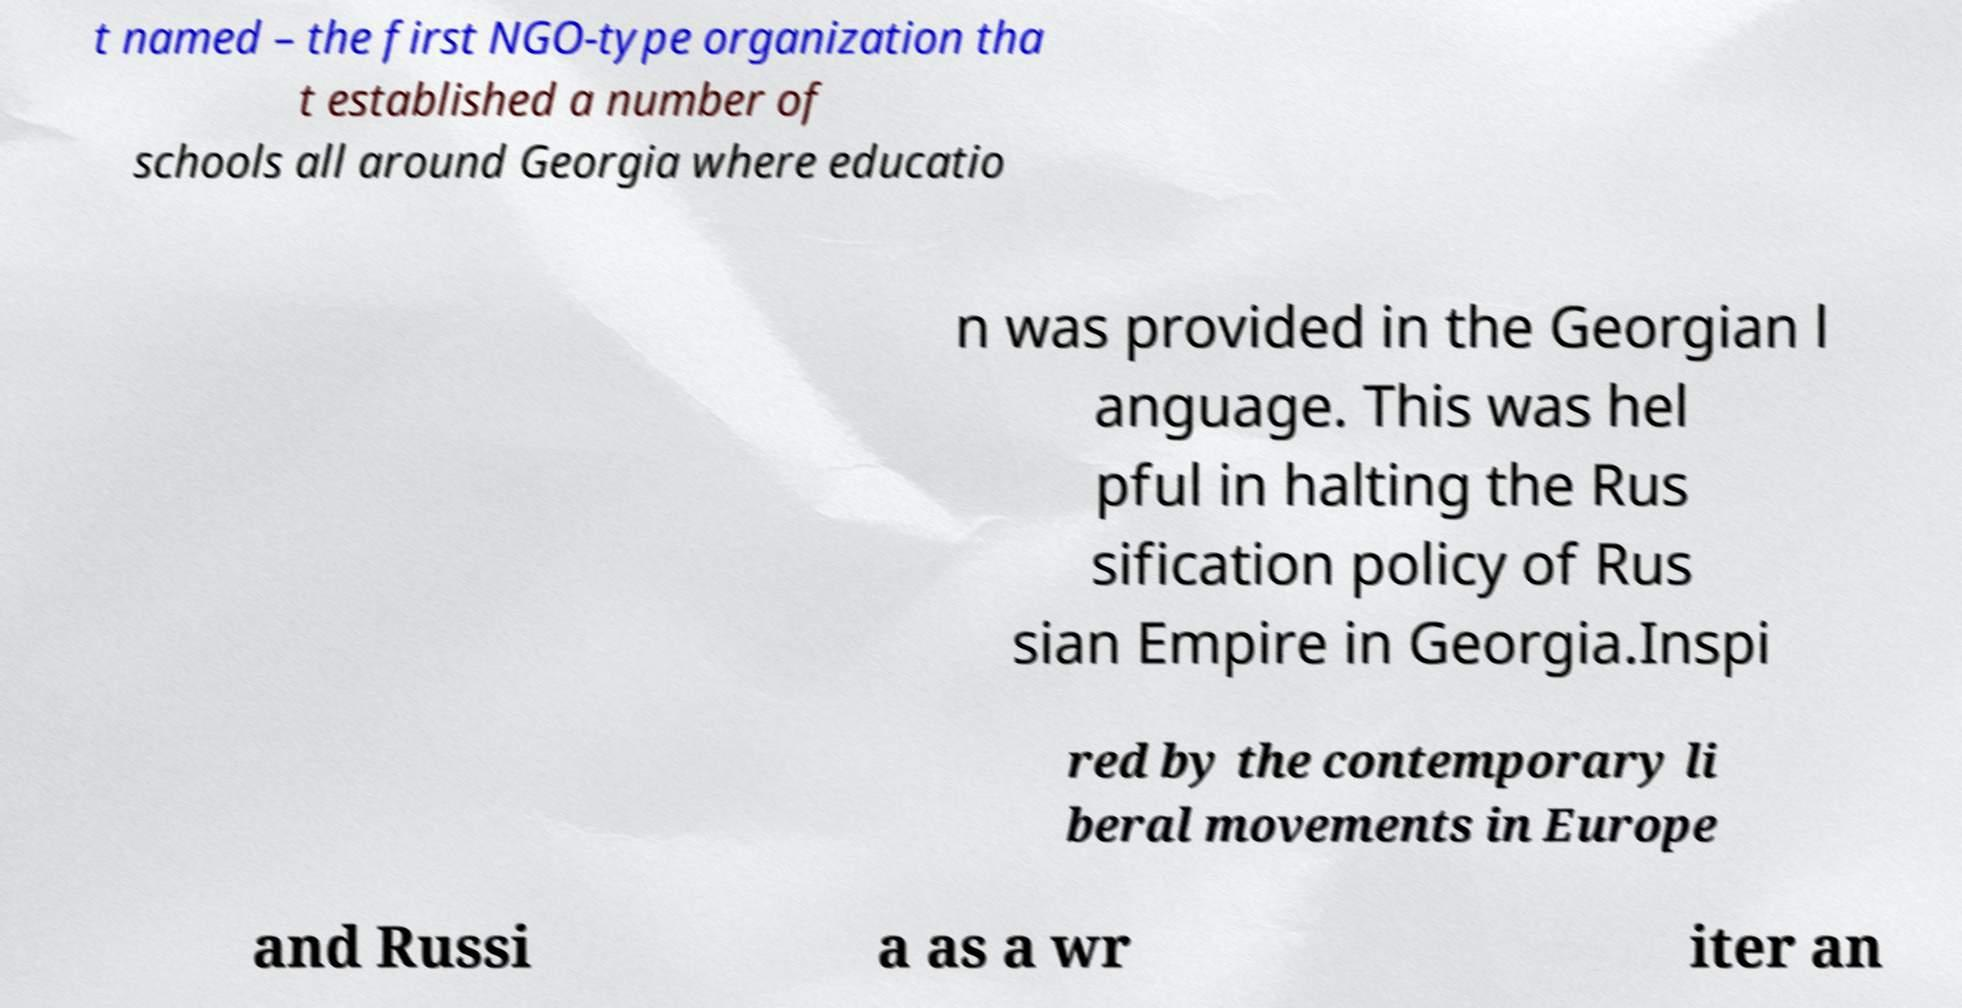Please identify and transcribe the text found in this image. t named – the first NGO-type organization tha t established a number of schools all around Georgia where educatio n was provided in the Georgian l anguage. This was hel pful in halting the Rus sification policy of Rus sian Empire in Georgia.Inspi red by the contemporary li beral movements in Europe and Russi a as a wr iter an 